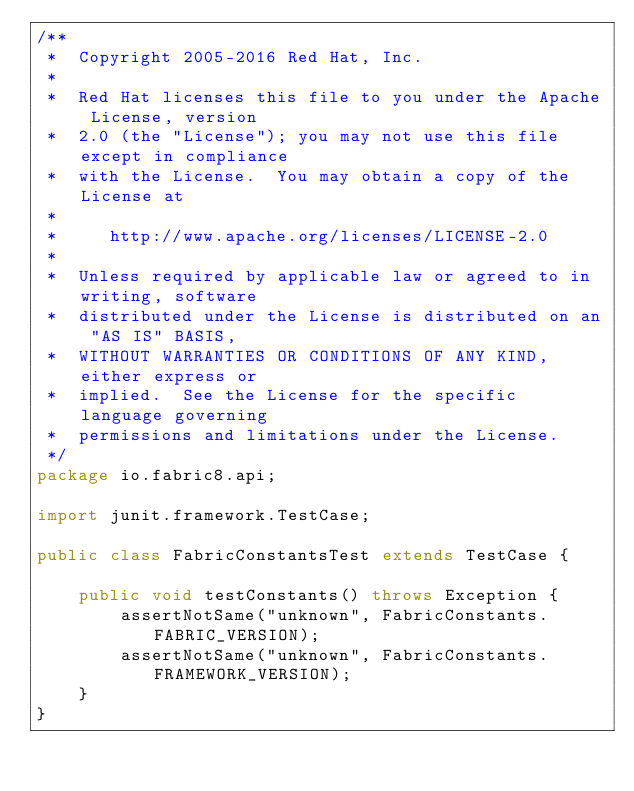<code> <loc_0><loc_0><loc_500><loc_500><_Java_>/**
 *  Copyright 2005-2016 Red Hat, Inc.
 *
 *  Red Hat licenses this file to you under the Apache License, version
 *  2.0 (the "License"); you may not use this file except in compliance
 *  with the License.  You may obtain a copy of the License at
 *
 *     http://www.apache.org/licenses/LICENSE-2.0
 *
 *  Unless required by applicable law or agreed to in writing, software
 *  distributed under the License is distributed on an "AS IS" BASIS,
 *  WITHOUT WARRANTIES OR CONDITIONS OF ANY KIND, either express or
 *  implied.  See the License for the specific language governing
 *  permissions and limitations under the License.
 */
package io.fabric8.api;

import junit.framework.TestCase;

public class FabricConstantsTest extends TestCase {

    public void testConstants() throws Exception {
        assertNotSame("unknown", FabricConstants.FABRIC_VERSION);
        assertNotSame("unknown", FabricConstants.FRAMEWORK_VERSION);
    }
}
</code> 